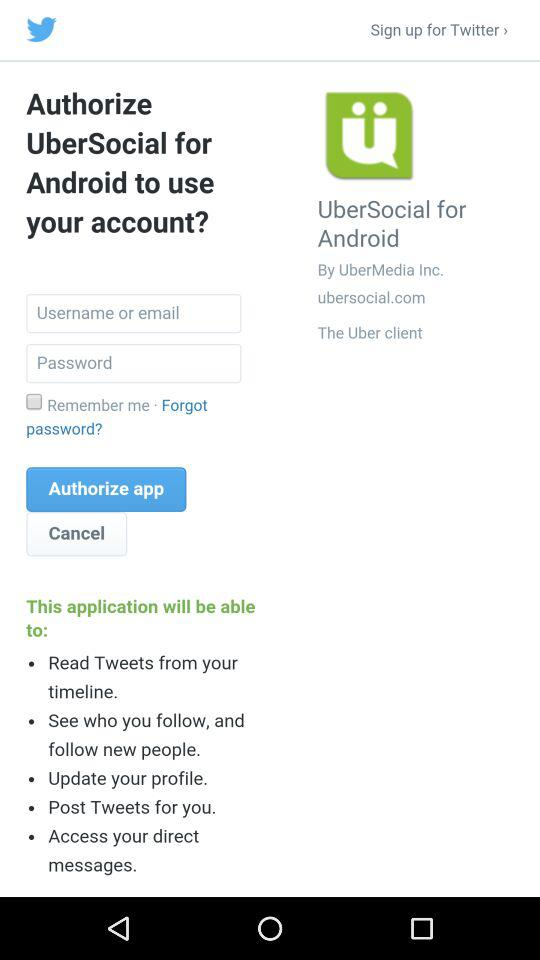What is the status of "Remember me"? The status is off. 